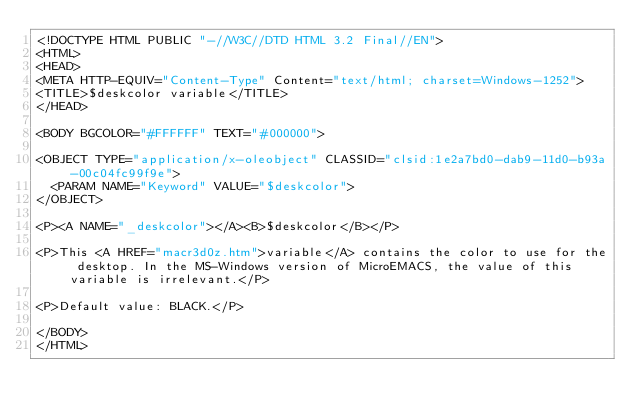Convert code to text. <code><loc_0><loc_0><loc_500><loc_500><_HTML_><!DOCTYPE HTML PUBLIC "-//W3C//DTD HTML 3.2 Final//EN">
<HTML>
<HEAD>
<META HTTP-EQUIV="Content-Type" Content="text/html; charset=Windows-1252">
<TITLE>$deskcolor variable</TITLE>
</HEAD>

<BODY BGCOLOR="#FFFFFF" TEXT="#000000">

<OBJECT TYPE="application/x-oleobject" CLASSID="clsid:1e2a7bd0-dab9-11d0-b93a-00c04fc99f9e">
	<PARAM NAME="Keyword" VALUE="$deskcolor">
</OBJECT>

<P><A NAME="_deskcolor"></A><B>$deskcolor</B></P>

<P>This <A HREF="macr3d0z.htm">variable</A> contains the color to use for the desktop. In the MS-Windows version of MicroEMACS, the value of this variable is irrelevant.</P>

<P>Default value: BLACK.</P>

</BODY>
</HTML>
</code> 